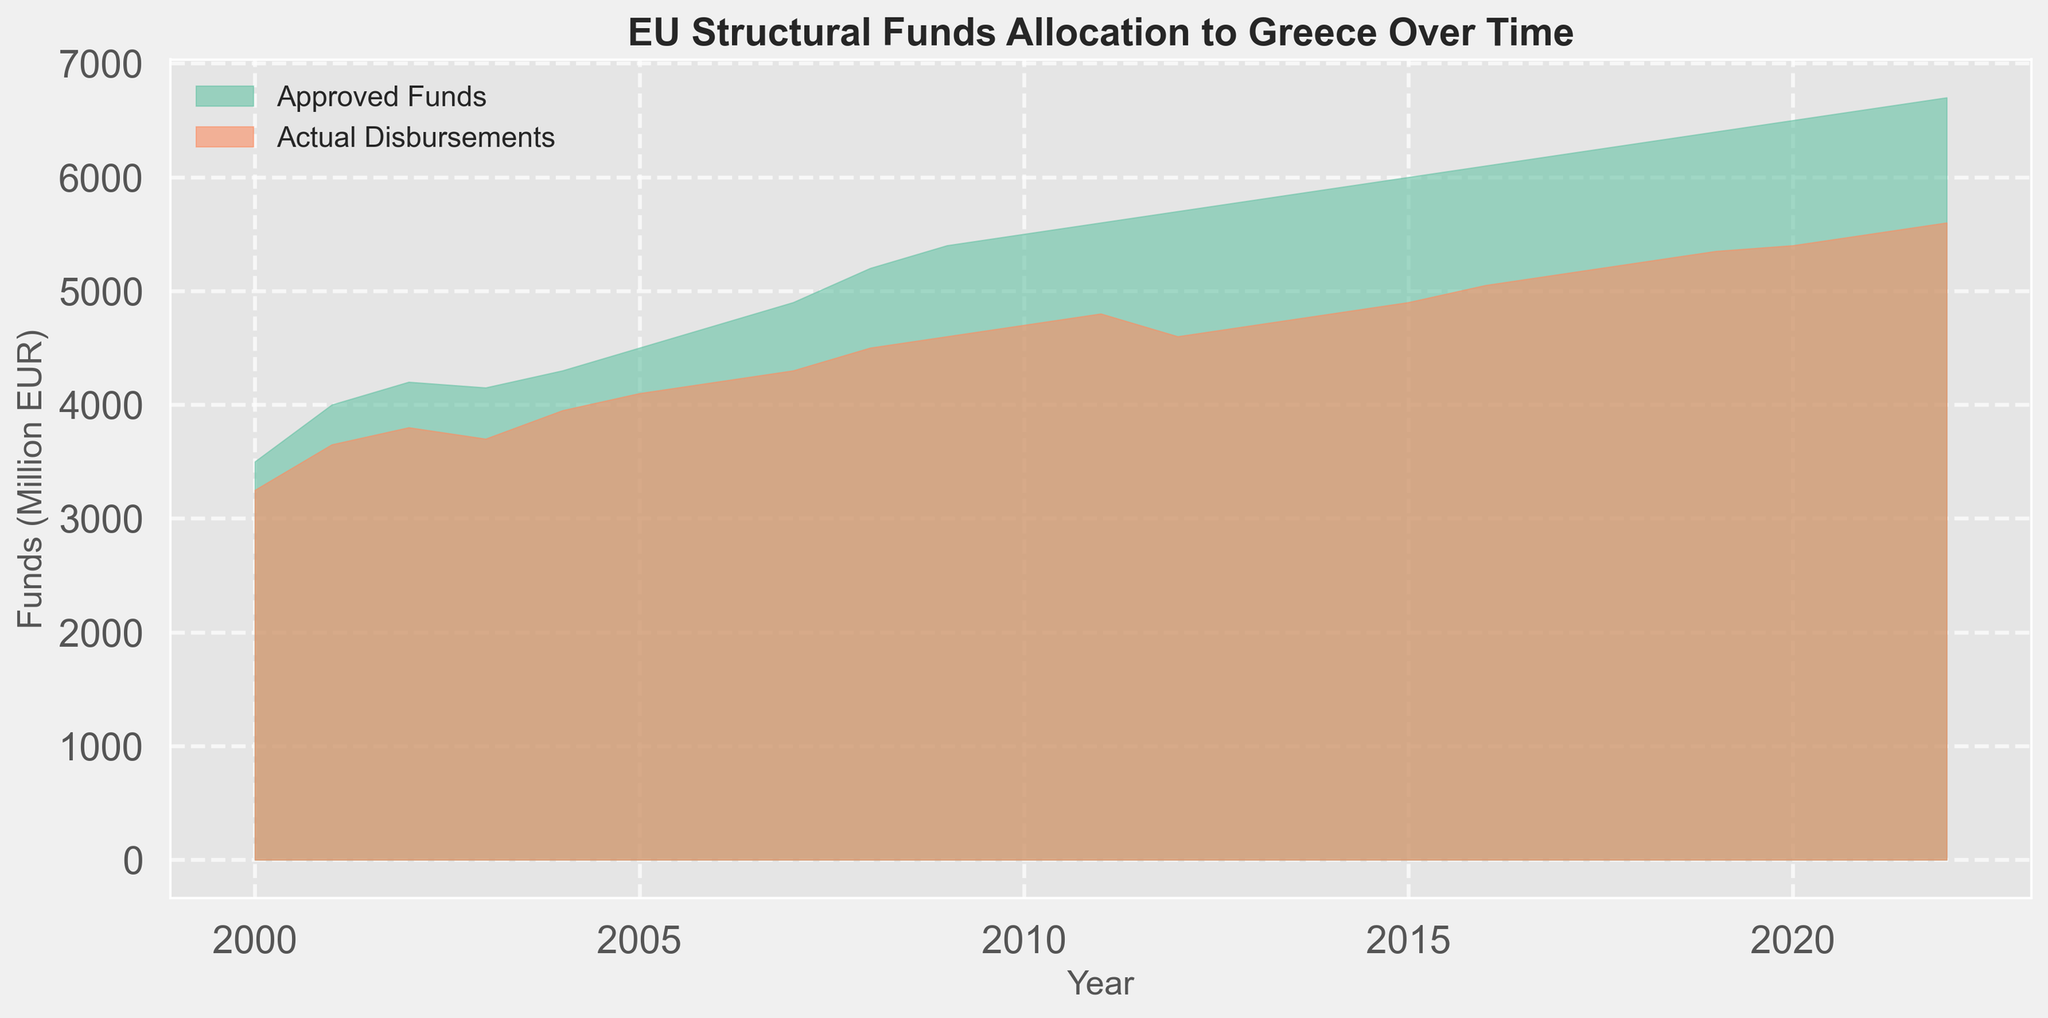How does the gap between approved funds and actual disbursements change over the years? To see how the gap changes, observe the space between the green (approved funds) and orange (actual disbursements) areas over time. The gap appears to be smaller in the early 2000s, then it widens around 2007-2015, and narrows again towards 2022.
Answer: The gap fluctuates, widens around 2007-2015, and narrows towards 2022 Which year had the smallest difference between approved funds and actual disbursements? Look for the year where the space between the green and orange areas is smallest. In the initial years like 2000, the difference is minimal.
Answer: 2000 What trend is observed in the actual disbursements from 2010 to 2015? Examine the height of the orange area between 2010 and 2015. The disbursements first rise from 2010 to 2011, fall in 2012, rise again until 2013, and then continue to rise up to 2015.
Answer: Fluctuating, initially rising, then falling, and rising again In which year did Greece receive the highest amount of actual disbursements and what was it? Identify the peak height of the orange area that represents actual disbursements. The highest point is in 2022.
Answer: 2022, 5600 million EUR How did the approved funds change between 2003 and 2005? Look at the height of the green area corresponding to the approved funds between 2003 and 2005. The approved funds slightly decreased from 4200 million EUR in 2003 to 4150 million EUR in 2004 and then increased to 4500 million EUR in 2005.
Answer: First decreased, then increased Were there any years where the actual disbursements exceeded approved funds? Compare the height of the orange area (disbursements) to the green area (approved funds). There are no years where actual disbursements exceed approved funds.
Answer: No By how much did the actual disbursements in 2021 differ from those in 2020? Subtract the actual disbursements value in 2020 (5400 million EUR) from the value in 2021 (5500 million EUR). 5500 - 5400 = 100.
Answer: 100 million EUR Which had a higher growth rate from 2000 to 2022, approved funds or actual disbursements? Calculate the percentage increase for both. For approved funds: ((6700-3500)/3500)*100; for actual disbursements: ((5600-3250)/3250)*100. 6700 is 91.4% higher than 3500, while 5600 is 72.3% higher than 3250.
Answer: Approved funds What was the average actual disbursement amount from 2015 to 2020? Add the total disbursements from 2015-2020 and divide by the number of years. (4900+5050+5150+5250+5350+5400)/6 = 5100 million EUR.
Answer: 5100 million EUR During which period did the approved funds increase the most rapidly? Look at the slope of the green area over different periods. The most rapid increase in the approved funds is from 2007 to 2012, where the increase is more pronounced.
Answer: 2007 to 2012 